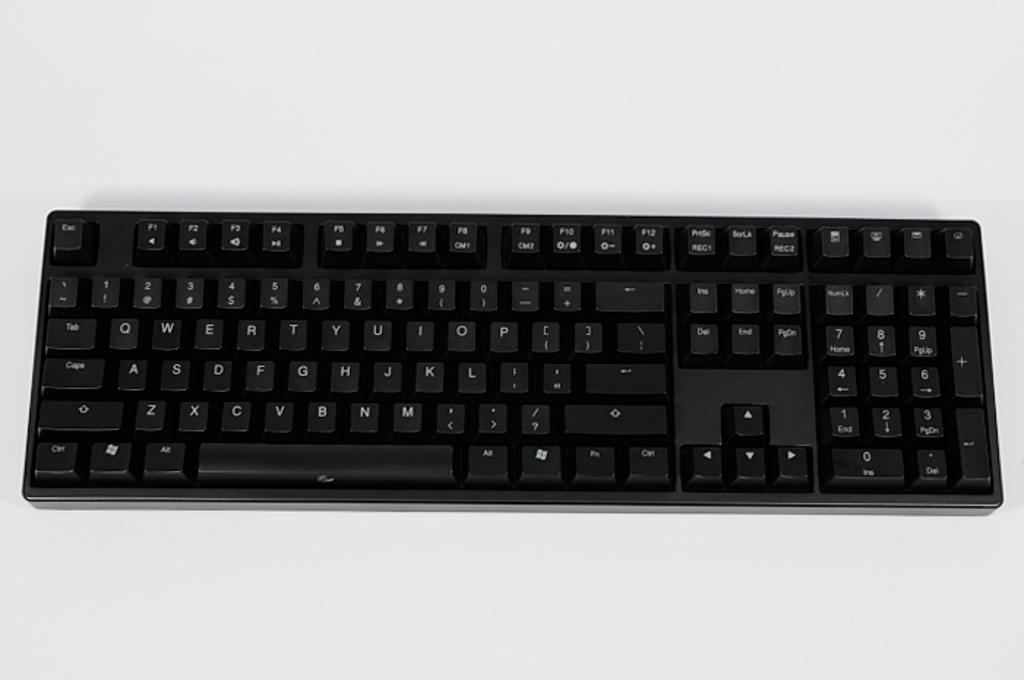<image>
Provide a brief description of the given image. A standard computer keyboard which is black in color with the keys written in white like the esc and space keys. 